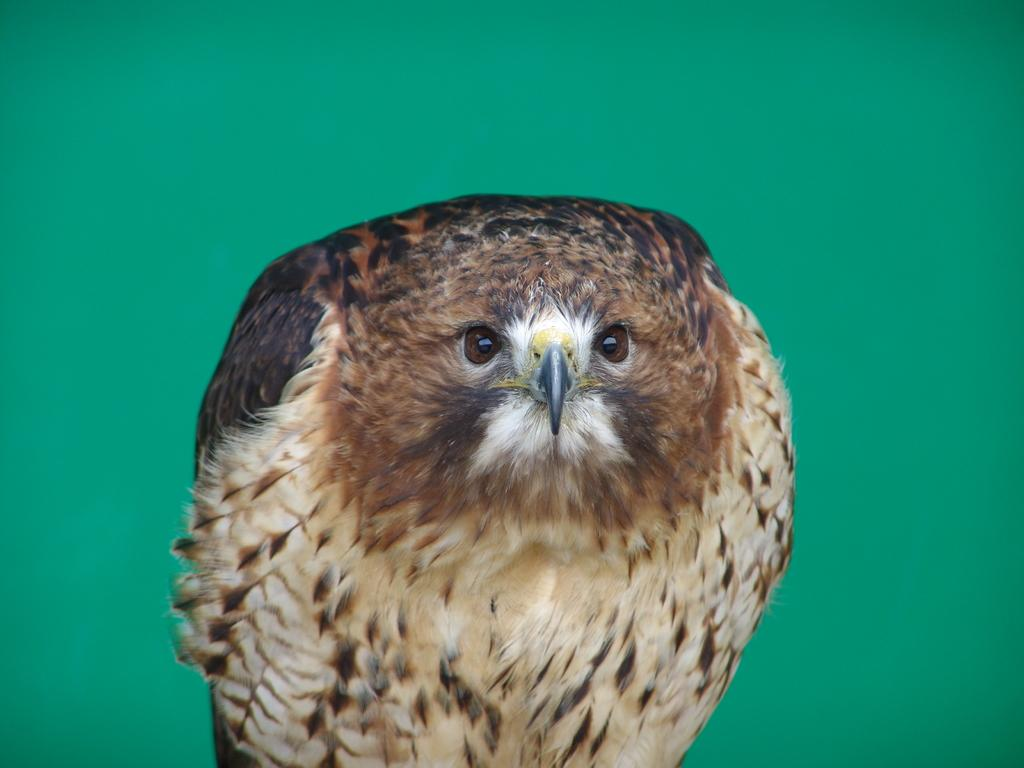What type of animal is in the image? There is an eagle in the image. What color is the background of the image? The background of the image is green in color. What type of wind instrument can be seen in the image? There is no wind instrument present in the image; it features an eagle and a green background. Where is the pipe located in the image? There is no pipe present in the image. What type of object is the eagle perched on in the image? The provided facts do not mention any object that the eagle is perched on. 